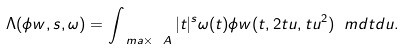Convert formula to latex. <formula><loc_0><loc_0><loc_500><loc_500>\Lambda ( \phi w , s , \omega ) = \int _ { \ m a \times \ A } | t | ^ { s } \omega ( t ) \phi w ( t , 2 t u , t u ^ { 2 } ) \ m d t d u .</formula> 